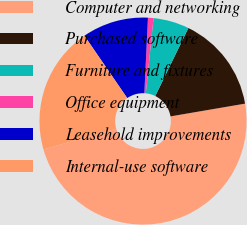Convert chart. <chart><loc_0><loc_0><loc_500><loc_500><pie_chart><fcel>Computer and networking<fcel>Purchased software<fcel>Furniture and fixtures<fcel>Office equipment<fcel>Leasehold improvements<fcel>Internal-use software<nl><fcel>48.29%<fcel>15.09%<fcel>5.6%<fcel>0.86%<fcel>10.34%<fcel>19.83%<nl></chart> 